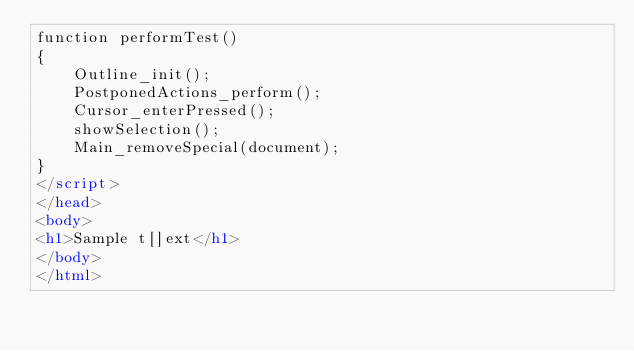Convert code to text. <code><loc_0><loc_0><loc_500><loc_500><_HTML_>function performTest()
{
    Outline_init();
    PostponedActions_perform();
    Cursor_enterPressed();
    showSelection();
    Main_removeSpecial(document);
}
</script>
</head>
<body>
<h1>Sample t[]ext</h1>
</body>
</html>
</code> 